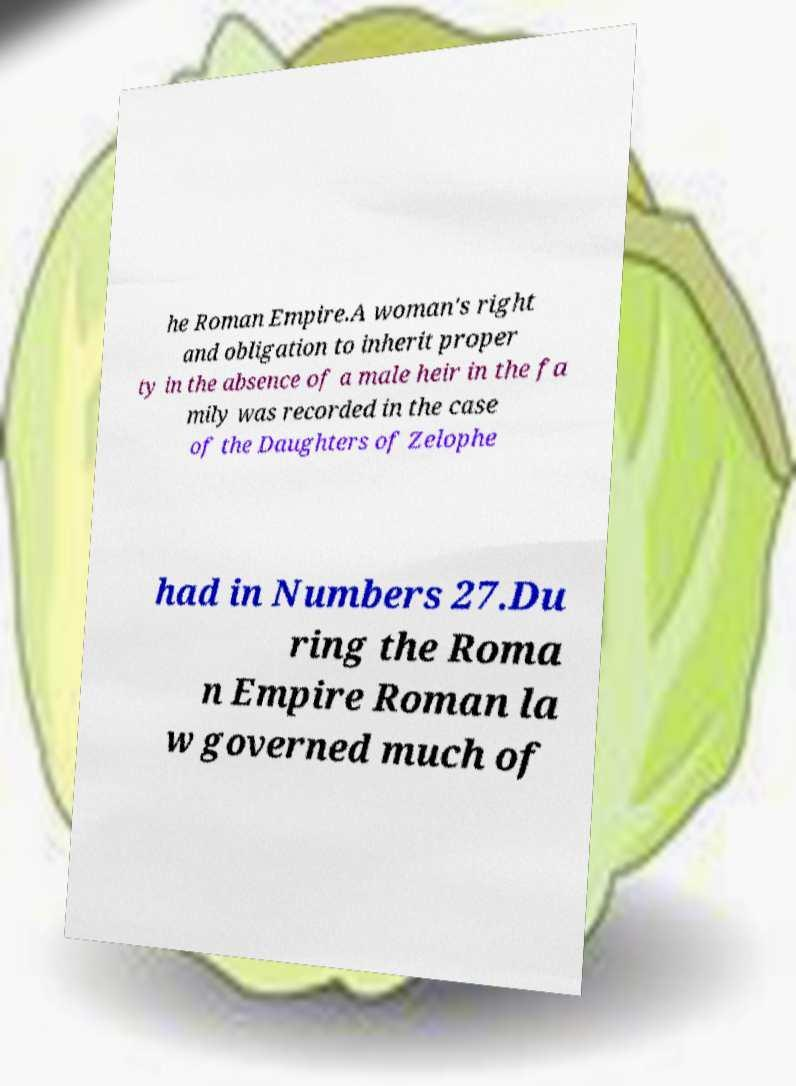Can you accurately transcribe the text from the provided image for me? he Roman Empire.A woman's right and obligation to inherit proper ty in the absence of a male heir in the fa mily was recorded in the case of the Daughters of Zelophe had in Numbers 27.Du ring the Roma n Empire Roman la w governed much of 